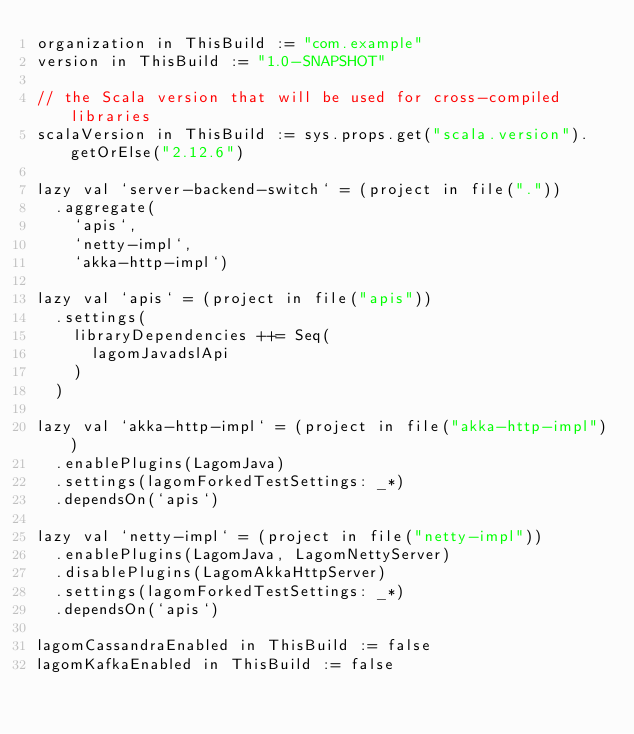Convert code to text. <code><loc_0><loc_0><loc_500><loc_500><_Scala_>organization in ThisBuild := "com.example"
version in ThisBuild := "1.0-SNAPSHOT"

// the Scala version that will be used for cross-compiled libraries
scalaVersion in ThisBuild := sys.props.get("scala.version").getOrElse("2.12.6")

lazy val `server-backend-switch` = (project in file("."))
  .aggregate(
    `apis`,
    `netty-impl`,
    `akka-http-impl`)

lazy val `apis` = (project in file("apis"))
  .settings(
    libraryDependencies ++= Seq(
      lagomJavadslApi
    )
  )

lazy val `akka-http-impl` = (project in file("akka-http-impl"))
  .enablePlugins(LagomJava)
  .settings(lagomForkedTestSettings: _*)
  .dependsOn(`apis`)

lazy val `netty-impl` = (project in file("netty-impl"))
  .enablePlugins(LagomJava, LagomNettyServer)
  .disablePlugins(LagomAkkaHttpServer)
  .settings(lagomForkedTestSettings: _*)
  .dependsOn(`apis`)

lagomCassandraEnabled in ThisBuild := false
lagomKafkaEnabled in ThisBuild := false
</code> 